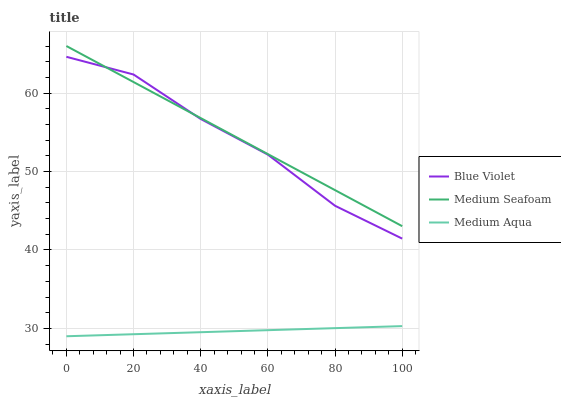Does Blue Violet have the minimum area under the curve?
Answer yes or no. No. Does Blue Violet have the maximum area under the curve?
Answer yes or no. No. Is Medium Seafoam the smoothest?
Answer yes or no. No. Is Medium Seafoam the roughest?
Answer yes or no. No. Does Blue Violet have the lowest value?
Answer yes or no. No. Does Blue Violet have the highest value?
Answer yes or no. No. Is Medium Aqua less than Blue Violet?
Answer yes or no. Yes. Is Medium Seafoam greater than Medium Aqua?
Answer yes or no. Yes. Does Medium Aqua intersect Blue Violet?
Answer yes or no. No. 